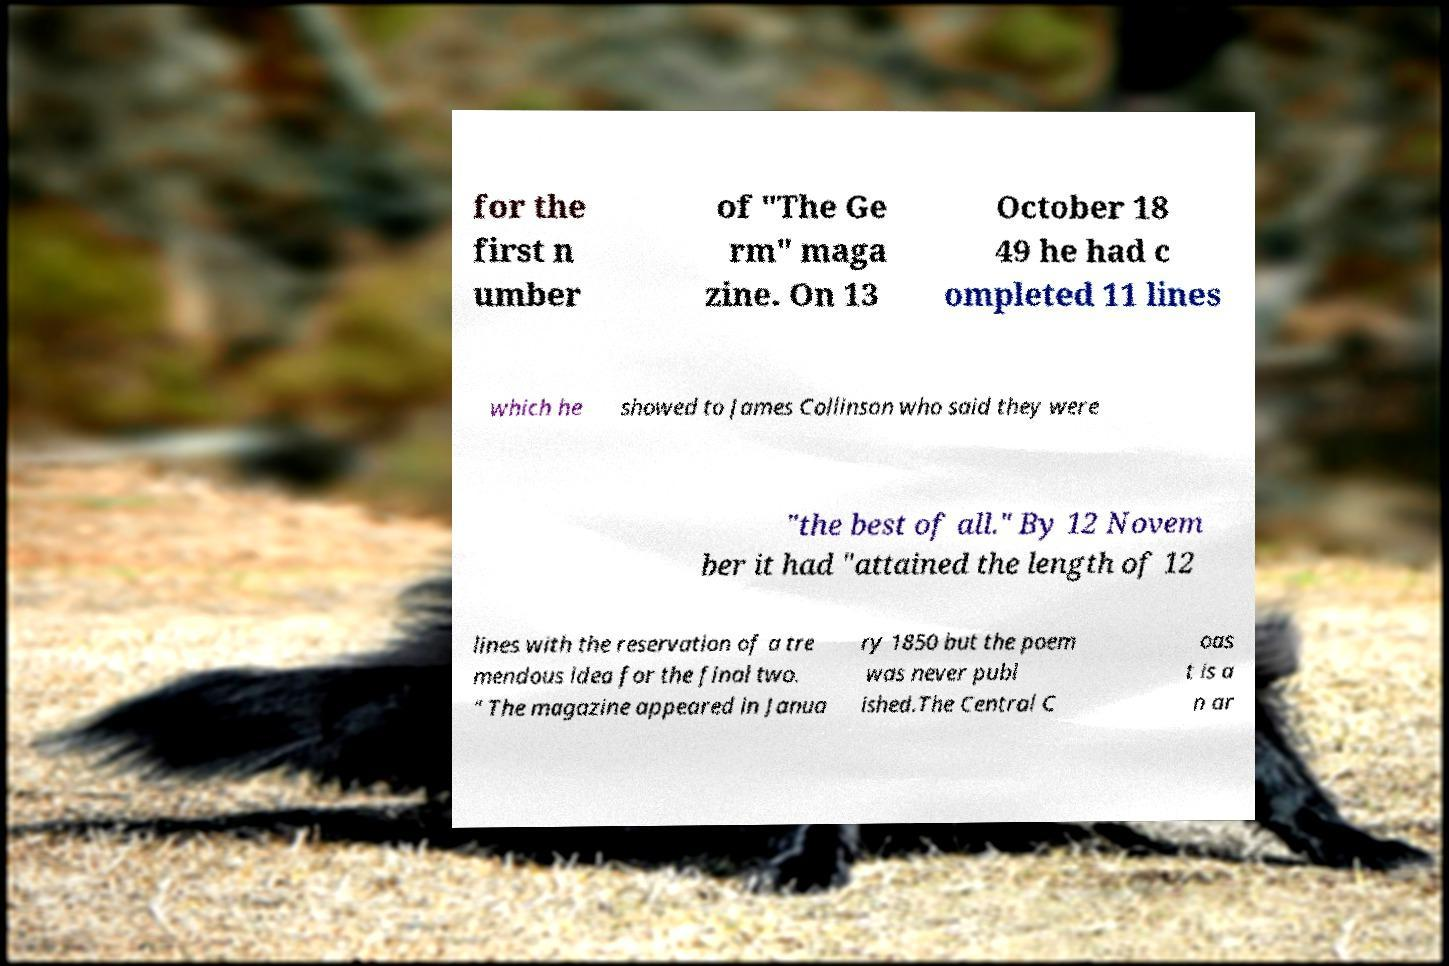Can you accurately transcribe the text from the provided image for me? for the first n umber of "The Ge rm" maga zine. On 13 October 18 49 he had c ompleted 11 lines which he showed to James Collinson who said they were "the best of all." By 12 Novem ber it had "attained the length of 12 lines with the reservation of a tre mendous idea for the final two. " The magazine appeared in Janua ry 1850 but the poem was never publ ished.The Central C oas t is a n ar 